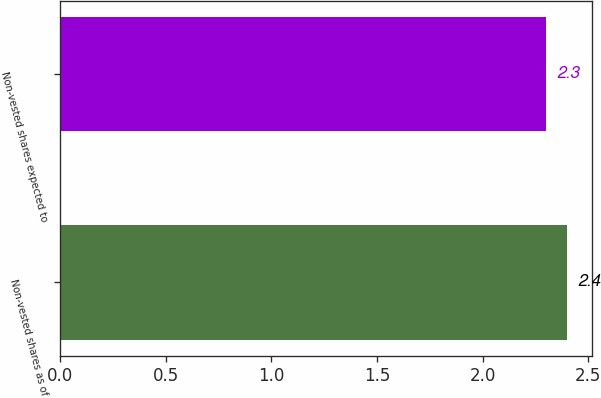Convert chart. <chart><loc_0><loc_0><loc_500><loc_500><bar_chart><fcel>Non-vested shares as of<fcel>Non-vested shares expected to<nl><fcel>2.4<fcel>2.3<nl></chart> 